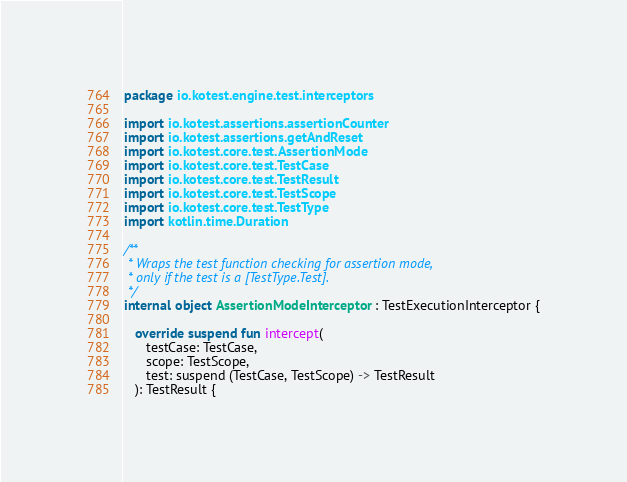Convert code to text. <code><loc_0><loc_0><loc_500><loc_500><_Kotlin_>package io.kotest.engine.test.interceptors

import io.kotest.assertions.assertionCounter
import io.kotest.assertions.getAndReset
import io.kotest.core.test.AssertionMode
import io.kotest.core.test.TestCase
import io.kotest.core.test.TestResult
import io.kotest.core.test.TestScope
import io.kotest.core.test.TestType
import kotlin.time.Duration

/**
 * Wraps the test function checking for assertion mode,
 * only if the test is a [TestType.Test].
 */
internal object AssertionModeInterceptor : TestExecutionInterceptor {

   override suspend fun intercept(
      testCase: TestCase,
      scope: TestScope,
      test: suspend (TestCase, TestScope) -> TestResult
   ): TestResult {
</code> 